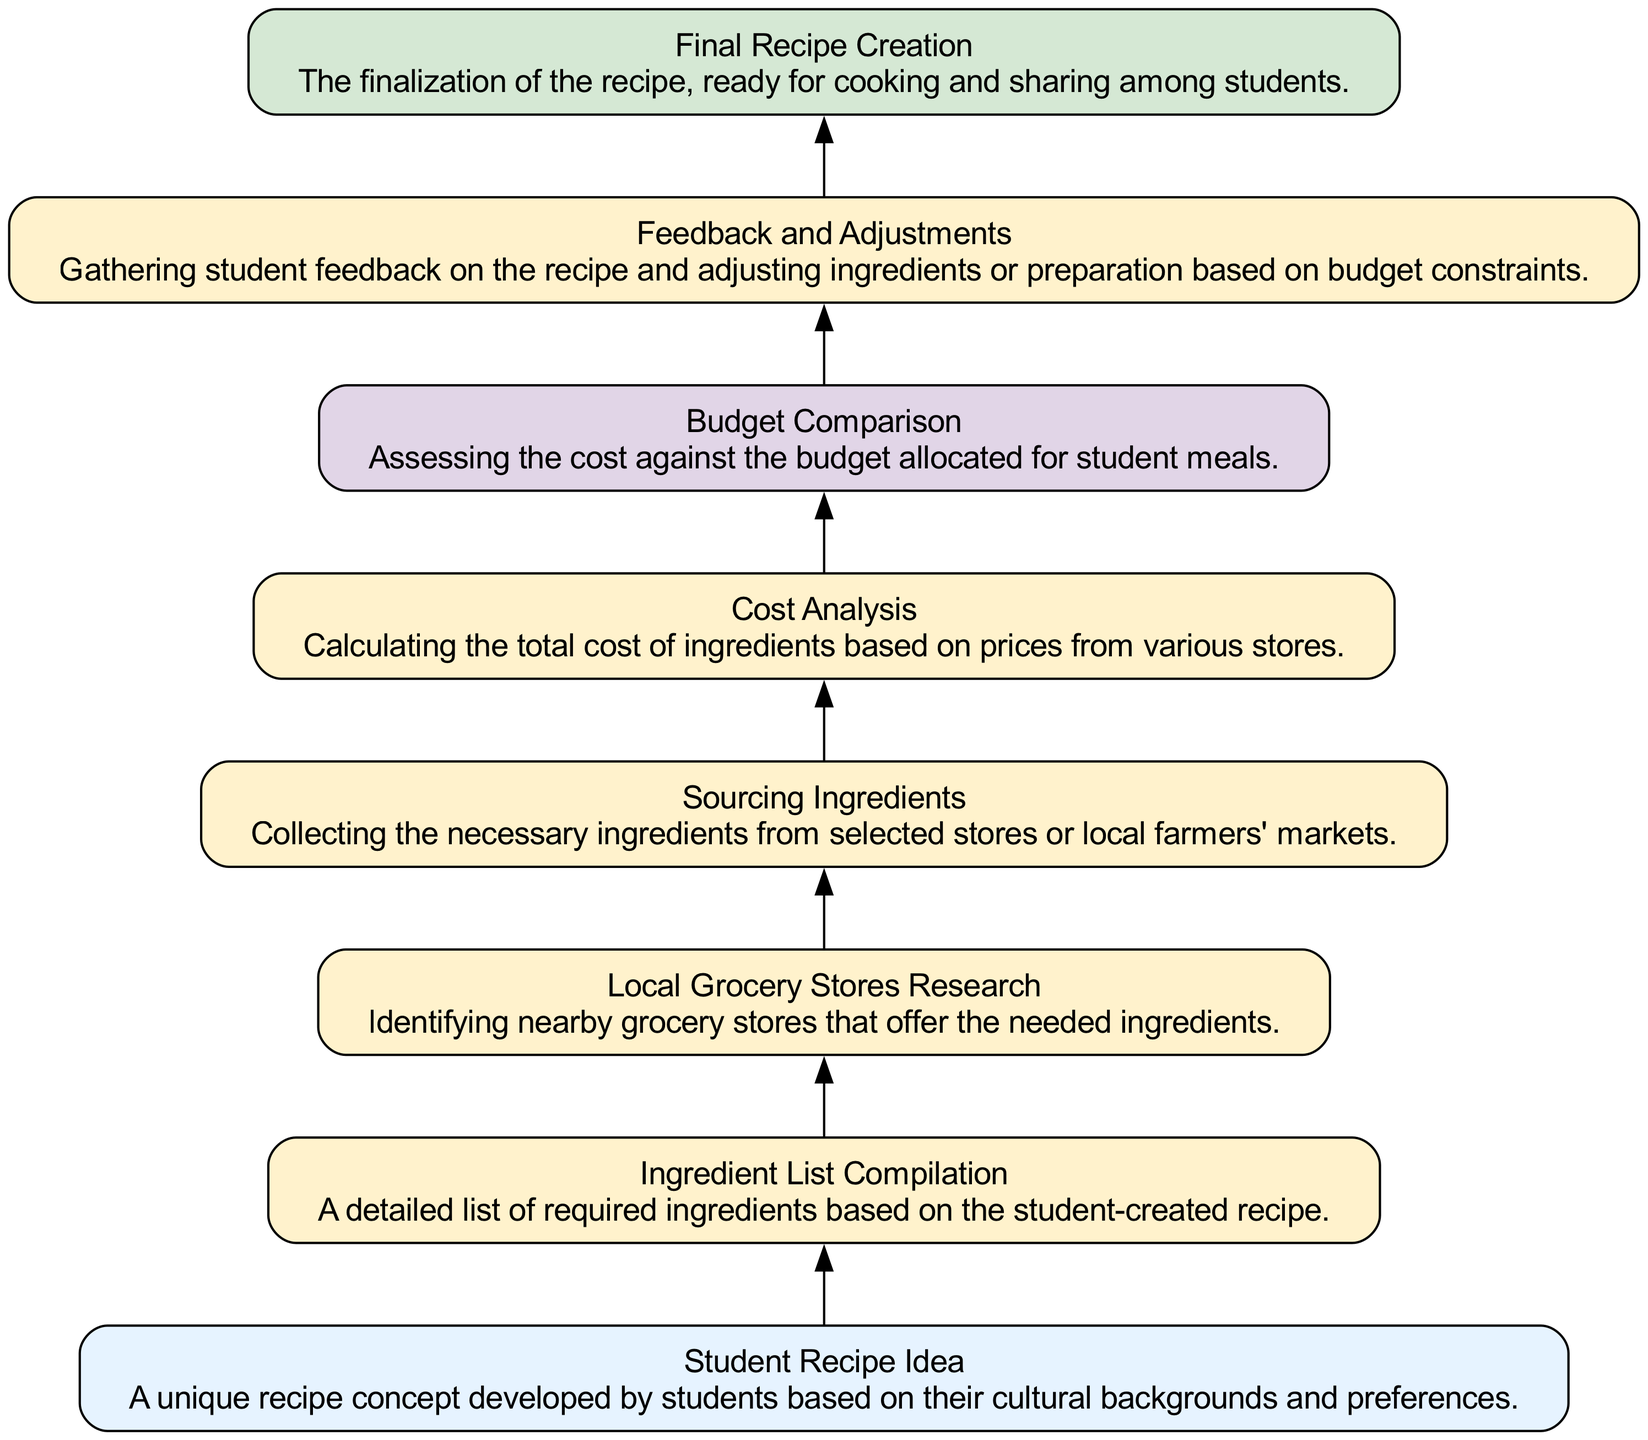What is the first step in the diagram? The first step in the diagram is labeled "Student Recipe Idea," indicating it as the initial input where students brainstorm a new recipe.
Answer: Student Recipe Idea How many process steps are in the diagram? By counting the number of elements labeled as "Process," we find that there are five processes: Ingredient List Compilation, Local Grocery Stores Research, Sourcing Ingredients, Cost Analysis, and Feedback and Adjustments.
Answer: Five What comes after the "Cost Analysis" step? The next step following "Cost Analysis" is "Budget Comparison," which is another decision point in the flow.
Answer: Budget Comparison Which node represents a decision in the process? In the flowchart, "Budget Comparison" is marked as the decision point, where the cost is assessed against the budget.
Answer: Budget Comparison What is the final output of the process? The diagram culminates in a final output labeled "Final Recipe Creation," indicating the completion of the recipe ready for sharing.
Answer: Final Recipe Creation What is the relationship between "Ingredient List Compilation" and "Sourcing Ingredients"? "Ingredient List Compilation" is the process that directly precedes "Sourcing Ingredients," meaning that the ingredient list must be compiled before sourcing can occur.
Answer: Directly precedes How many edges connect the nodes in the flow chart? Each node is connected to the next through edges. Counting these connections reveals there are six edges connecting the seven nodes together in the chart.
Answer: Six What action follows the "Feedback and Adjustments"? After "Feedback and Adjustments," the process leads to "Final Recipe Creation," finalizing the recipe based on gathered feedback.
Answer: Final Recipe Creation 